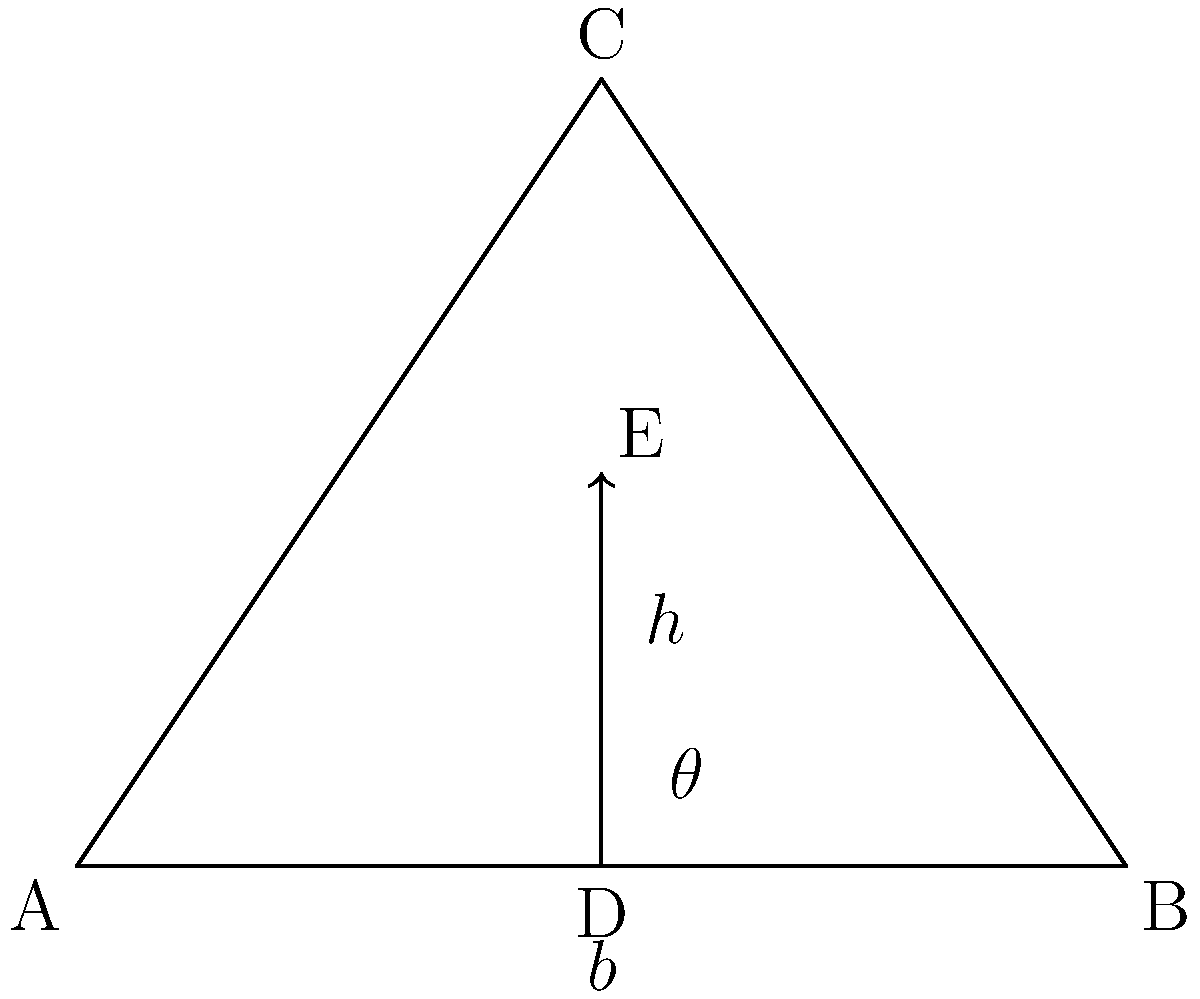In a futuristic club setting, you're designing a triangular LED screen array for maximum visual impact. The screen is represented by triangle ABC, with base $b = 4$ meters and height $h = 3$ meters. To optimize visibility, you need to tilt the screen at an angle $\theta$ from the horizontal. If you want the midpoint of the height (point E) to be exactly 1.5 meters above the base, what should be the tilt angle $\theta$? Let's approach this step-by-step:

1) In the triangle, we know:
   - Base (AB) = $b = 4$ meters
   - Height (CD) = $h = 3$ meters
   - Point E is the midpoint of CD, so DE = 1.5 meters

2) We need to find angle $\theta$ between AD and AB.

3) We can use the tangent function to find this angle:

   $\tan(\theta) = \frac{\text{opposite}}{\text{adjacent}} = \frac{DE}{AD}$

4) We know DE = 1.5 meters, but we need to find AD.

5) AD is half of the base AB:
   $AD = \frac{1}{2}AB = \frac{1}{2} \cdot 4 = 2$ meters

6) Now we can calculate $\tan(\theta)$:

   $\tan(\theta) = \frac{1.5}{2} = 0.75$

7) To find $\theta$, we need to use the inverse tangent (arctangent) function:

   $\theta = \arctan(0.75)$

8) Using a calculator or computer:

   $\theta \approx 36.87°$
Answer: $36.87°$ 